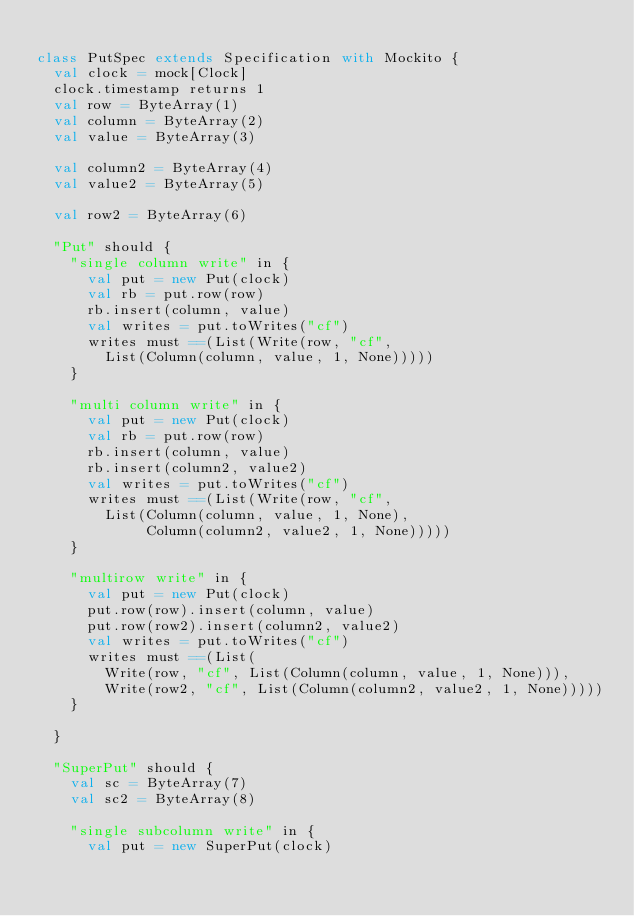Convert code to text. <code><loc_0><loc_0><loc_500><loc_500><_Scala_>
class PutSpec extends Specification with Mockito {
  val clock = mock[Clock]
  clock.timestamp returns 1
  val row = ByteArray(1)
  val column = ByteArray(2)
  val value = ByteArray(3)
  
  val column2 = ByteArray(4)
  val value2 = ByteArray(5)
  
  val row2 = ByteArray(6)
  
  "Put" should {
    "single column write" in {
      val put = new Put(clock)
      val rb = put.row(row)
      rb.insert(column, value)
      val writes = put.toWrites("cf")
      writes must ==(List(Write(row, "cf", 
        List(Column(column, value, 1, None)))))
    }
    
    "multi column write" in {
      val put = new Put(clock)
      val rb = put.row(row)
      rb.insert(column, value)
      rb.insert(column2, value2)
      val writes = put.toWrites("cf")
      writes must ==(List(Write(row, "cf",
        List(Column(column, value, 1, None),
             Column(column2, value2, 1, None)))))
    }
    
    "multirow write" in {
      val put = new Put(clock)
      put.row(row).insert(column, value)
      put.row(row2).insert(column2, value2)
      val writes = put.toWrites("cf")
      writes must ==(List(
        Write(row, "cf", List(Column(column, value, 1, None))),
        Write(row2, "cf", List(Column(column2, value2, 1, None)))))
    }
    
  }
  
  "SuperPut" should {
    val sc = ByteArray(7)
    val sc2 = ByteArray(8)
    
    "single subcolumn write" in {
      val put = new SuperPut(clock)</code> 